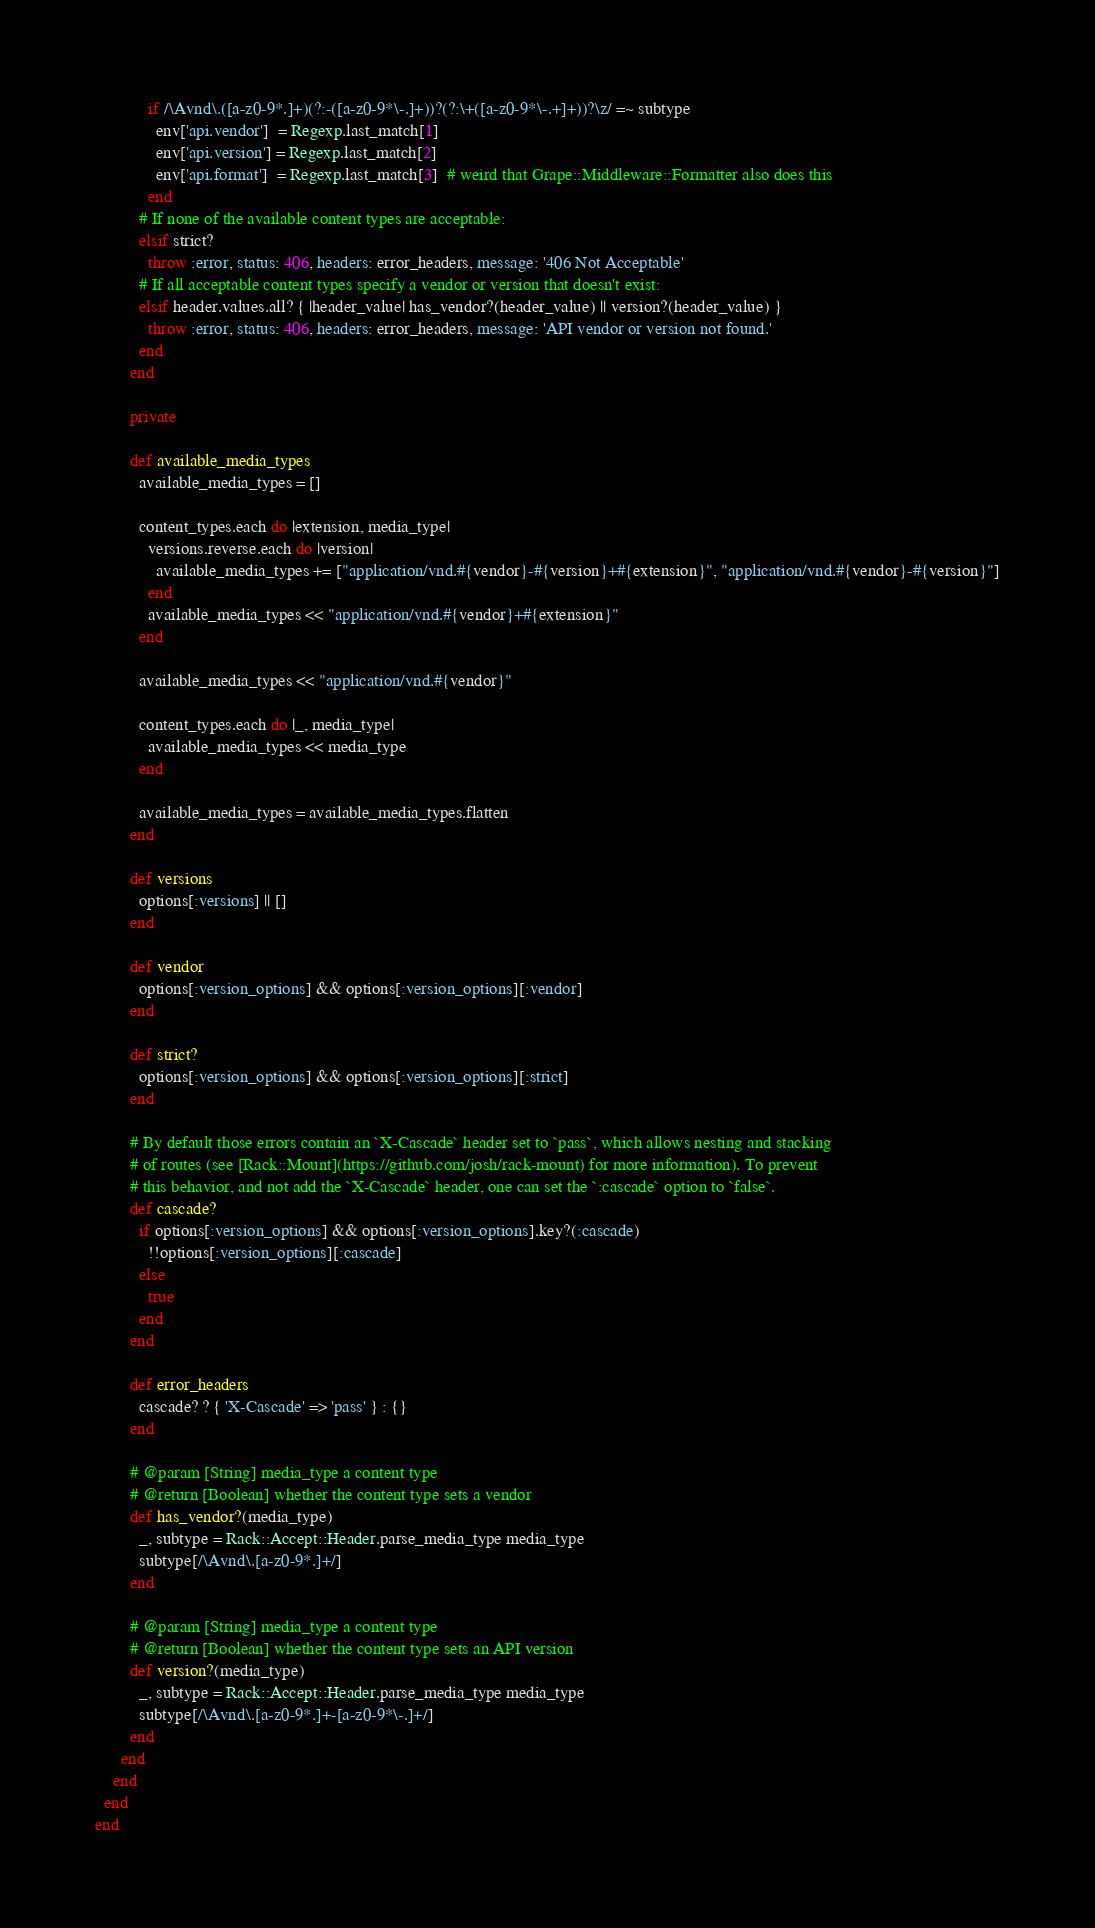Convert code to text. <code><loc_0><loc_0><loc_500><loc_500><_Ruby_>
            if /\Avnd\.([a-z0-9*.]+)(?:-([a-z0-9*\-.]+))?(?:\+([a-z0-9*\-.+]+))?\z/ =~ subtype
              env['api.vendor']  = Regexp.last_match[1]
              env['api.version'] = Regexp.last_match[2]
              env['api.format']  = Regexp.last_match[3]  # weird that Grape::Middleware::Formatter also does this
            end
          # If none of the available content types are acceptable:
          elsif strict?
            throw :error, status: 406, headers: error_headers, message: '406 Not Acceptable'
          # If all acceptable content types specify a vendor or version that doesn't exist:
          elsif header.values.all? { |header_value| has_vendor?(header_value) || version?(header_value) }
            throw :error, status: 406, headers: error_headers, message: 'API vendor or version not found.'
          end
        end

        private

        def available_media_types
          available_media_types = []

          content_types.each do |extension, media_type|
            versions.reverse.each do |version|
              available_media_types += ["application/vnd.#{vendor}-#{version}+#{extension}", "application/vnd.#{vendor}-#{version}"]
            end
            available_media_types << "application/vnd.#{vendor}+#{extension}"
          end

          available_media_types << "application/vnd.#{vendor}"

          content_types.each do |_, media_type|
            available_media_types << media_type
          end

          available_media_types = available_media_types.flatten
        end

        def versions
          options[:versions] || []
        end

        def vendor
          options[:version_options] && options[:version_options][:vendor]
        end

        def strict?
          options[:version_options] && options[:version_options][:strict]
        end

        # By default those errors contain an `X-Cascade` header set to `pass`, which allows nesting and stacking
        # of routes (see [Rack::Mount](https://github.com/josh/rack-mount) for more information). To prevent
        # this behavior, and not add the `X-Cascade` header, one can set the `:cascade` option to `false`.
        def cascade?
          if options[:version_options] && options[:version_options].key?(:cascade)
            !!options[:version_options][:cascade]
          else
            true
          end
        end

        def error_headers
          cascade? ? { 'X-Cascade' => 'pass' } : {}
        end

        # @param [String] media_type a content type
        # @return [Boolean] whether the content type sets a vendor
        def has_vendor?(media_type)
          _, subtype = Rack::Accept::Header.parse_media_type media_type
          subtype[/\Avnd\.[a-z0-9*.]+/]
        end

        # @param [String] media_type a content type
        # @return [Boolean] whether the content type sets an API version
        def version?(media_type)
          _, subtype = Rack::Accept::Header.parse_media_type media_type
          subtype[/\Avnd\.[a-z0-9*.]+-[a-z0-9*\-.]+/]
        end
      end
    end
  end
end
</code> 